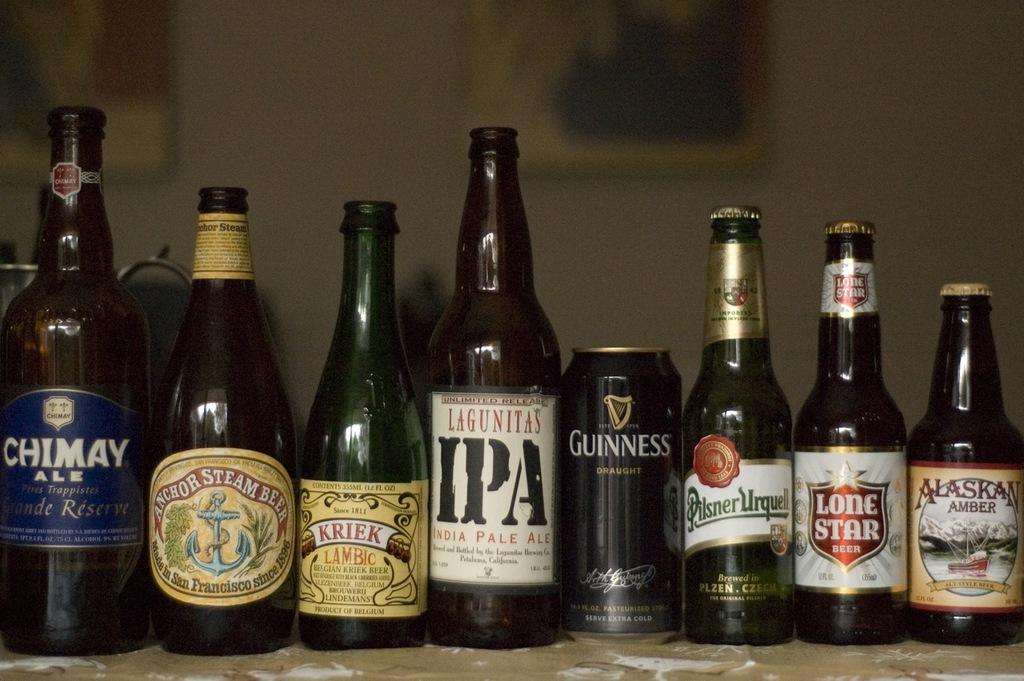Provide a one-sentence caption for the provided image. A number of bottles of beer and one can, including Guiness and Lone Star. 